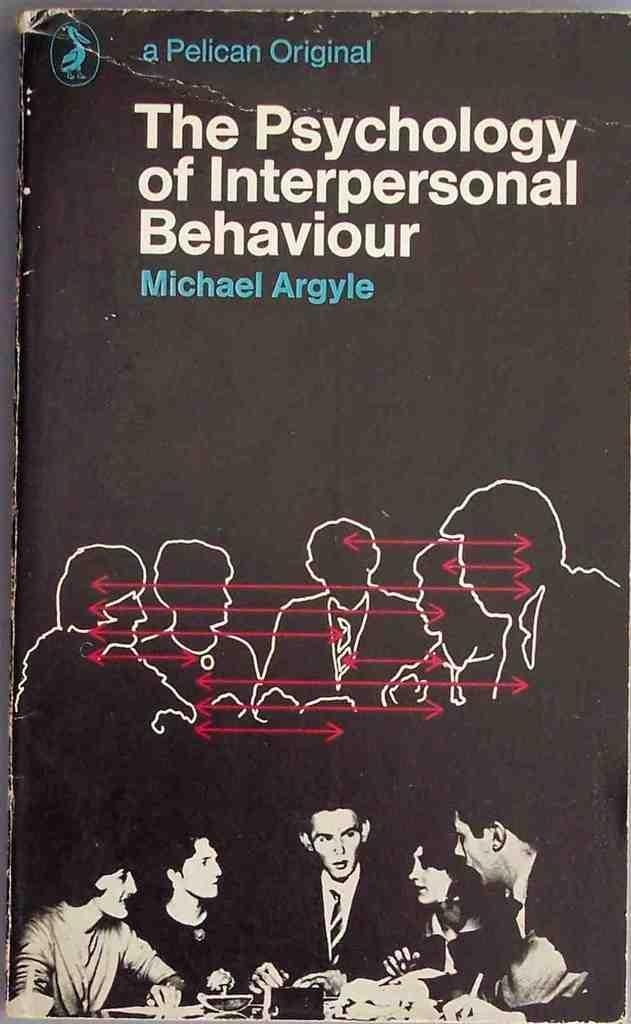Could you give a brief overview of what you see in this image? In this image we can see the top view of the book and on the book we can see the white and blue color text and also persons images are visible. 